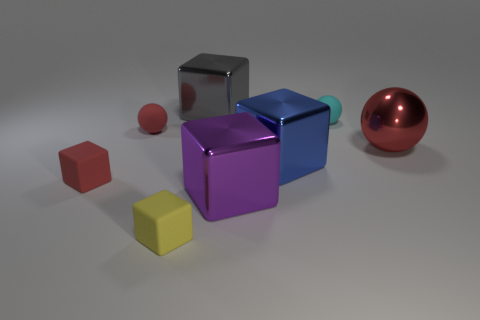What number of other things are there of the same material as the big red ball
Ensure brevity in your answer.  3. There is a sphere on the left side of the gray metal block; what is its size?
Your answer should be compact. Small. What is the shape of the big purple thing that is the same material as the big blue block?
Ensure brevity in your answer.  Cube. Do the cyan sphere and the tiny cube that is behind the purple metal thing have the same material?
Your response must be concise. Yes. There is a purple object to the right of the yellow thing; is its shape the same as the big blue shiny object?
Give a very brief answer. Yes. What is the material of the large blue object that is the same shape as the yellow object?
Your answer should be very brief. Metal. There is a cyan matte object; is its shape the same as the metal object that is on the right side of the blue object?
Give a very brief answer. Yes. The cube that is both behind the big purple metal thing and in front of the big blue thing is what color?
Ensure brevity in your answer.  Red. Are there any gray metallic blocks?
Ensure brevity in your answer.  Yes. Are there an equal number of red shiny balls behind the gray metal thing and large red balls?
Your answer should be compact. No. 